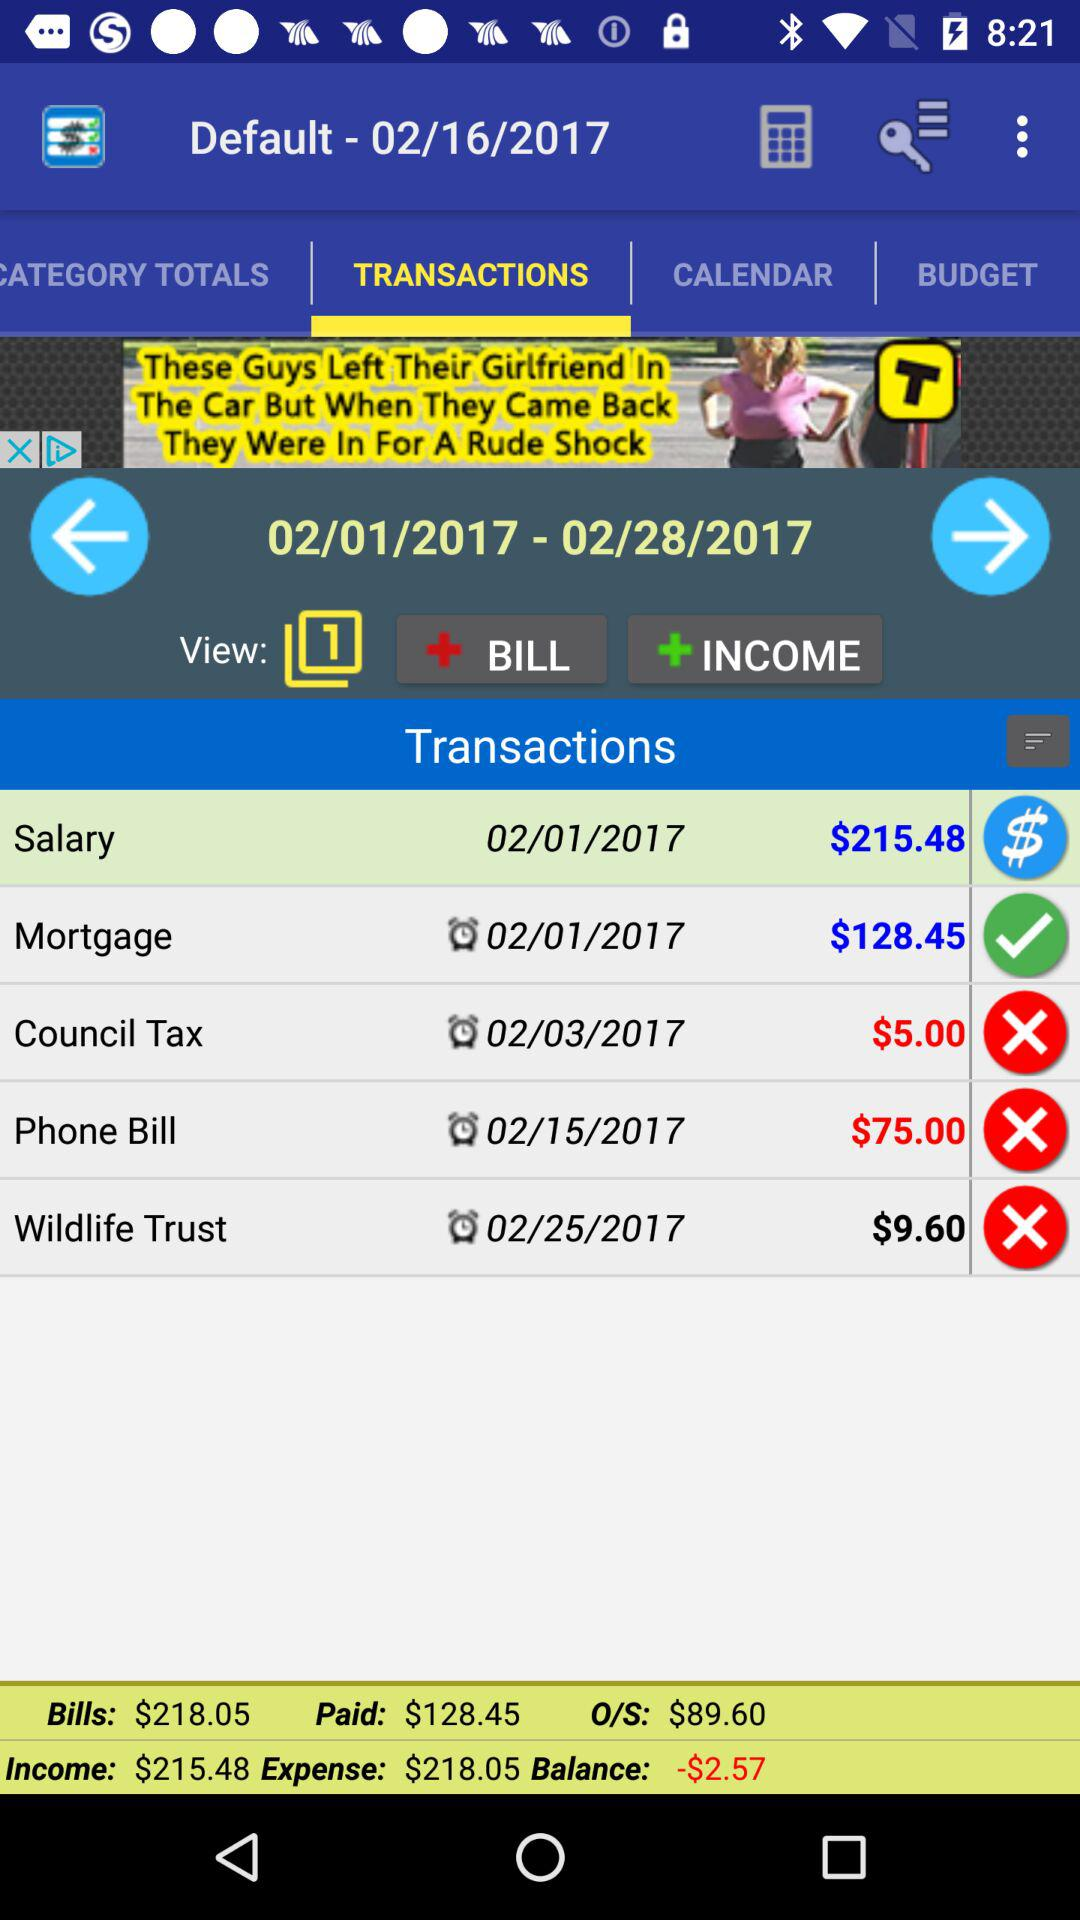What is the amount of the phone bill? The amount is $75. 